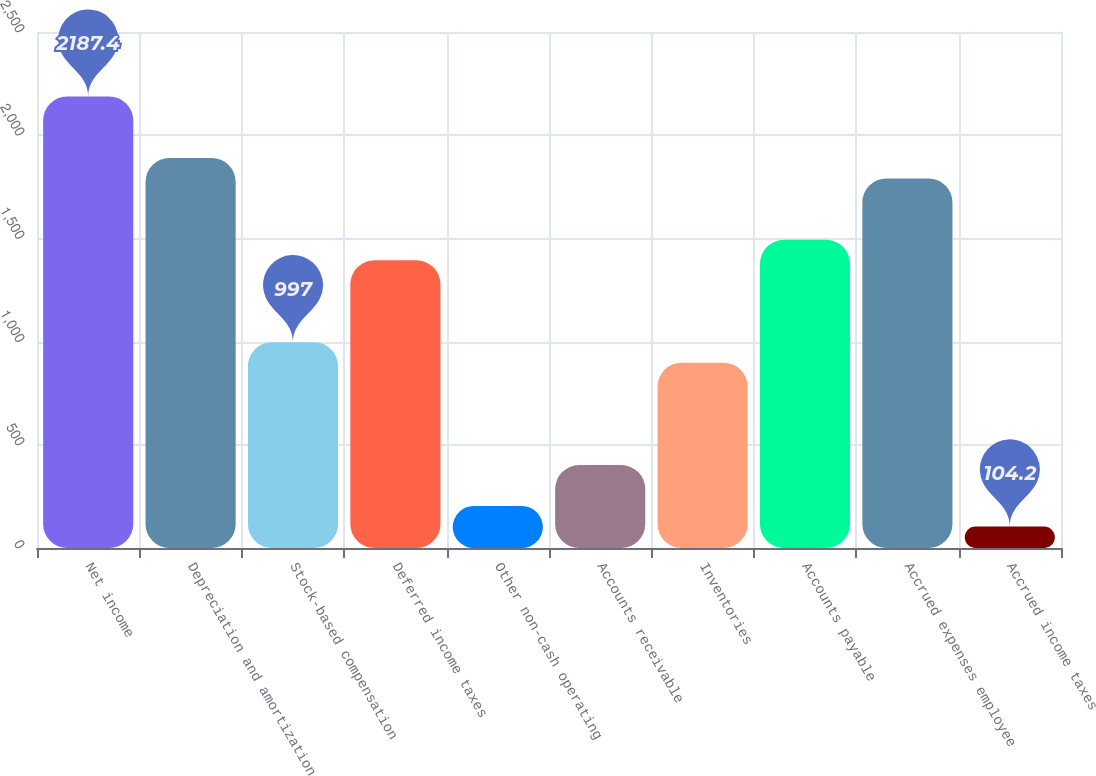Convert chart to OTSL. <chart><loc_0><loc_0><loc_500><loc_500><bar_chart><fcel>Net income<fcel>Depreciation and amortization<fcel>Stock-based compensation<fcel>Deferred income taxes<fcel>Other non-cash operating<fcel>Accounts receivable<fcel>Inventories<fcel>Accounts payable<fcel>Accrued expenses employee<fcel>Accrued income taxes<nl><fcel>2187.4<fcel>1889.8<fcel>997<fcel>1393.8<fcel>203.4<fcel>401.8<fcel>897.8<fcel>1493<fcel>1790.6<fcel>104.2<nl></chart> 